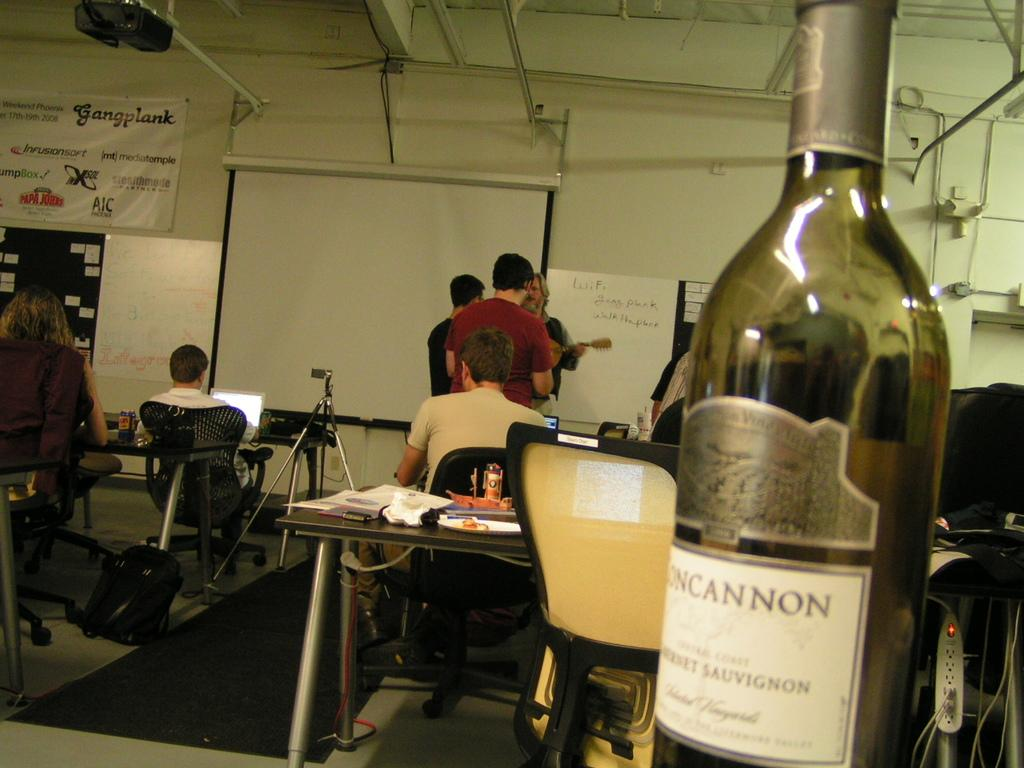<image>
Give a short and clear explanation of the subsequent image. People are in a classroom with a banner that says "Gangplank". 